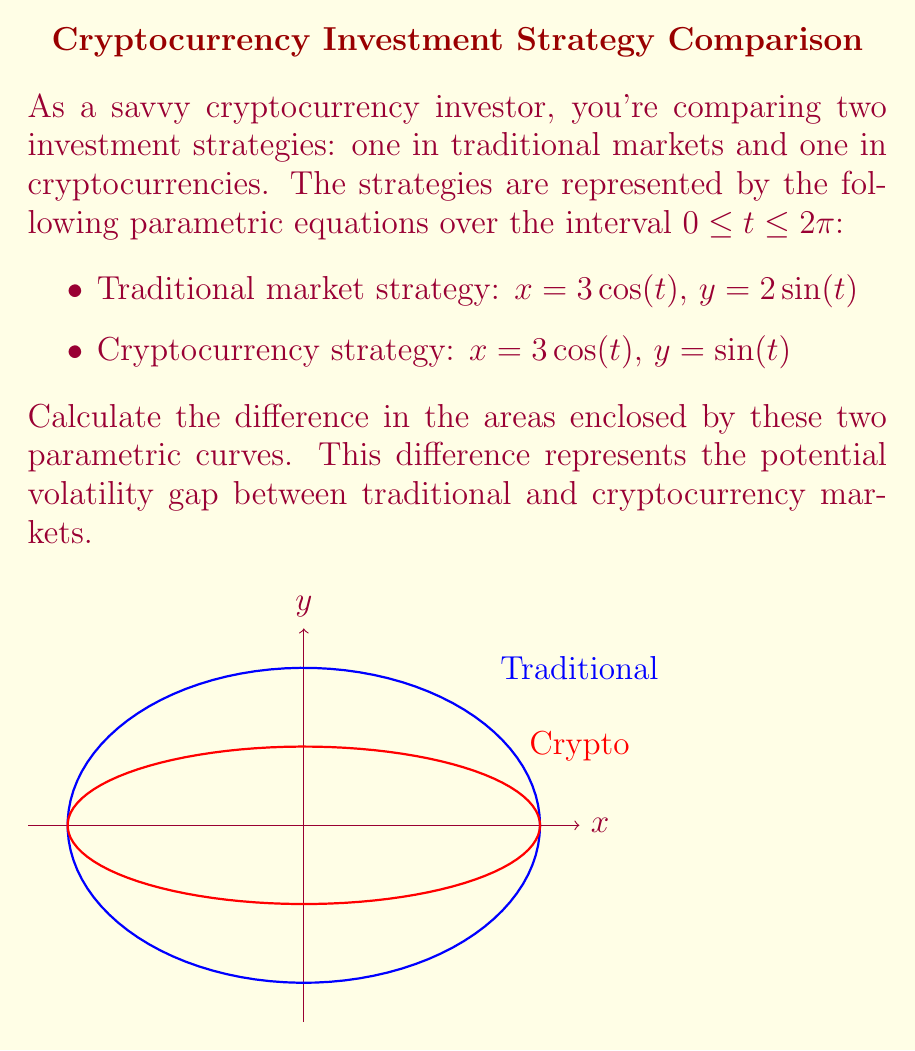Teach me how to tackle this problem. Let's approach this step-by-step:

1) For a parametric curve $(x(t), y(t))$ over an interval $[a,b]$, the area enclosed is given by the formula:

   $$A = \frac{1}{2}\int_a^b [x(t)y'(t) - y(t)x'(t)] dt$$

2) For the traditional market strategy:
   $x = 3\cos(t)$, $y = 2\sin(t)$
   $x' = -3\sin(t)$, $y' = 2\cos(t)$

   $$A_1 = \frac{1}{2}\int_0^{2\pi} [3\cos(t)(2\cos(t)) - 2\sin(t)(-3\sin(t))] dt$$
   $$= \frac{1}{2}\int_0^{2\pi} [6\cos^2(t) + 6\sin^2(t)] dt$$
   $$= \frac{1}{2}\int_0^{2\pi} 6 dt = 3\pi$$

3) For the cryptocurrency strategy:
   $x = 3\cos(t)$, $y = \sin(t)$
   $x' = -3\sin(t)$, $y' = \cos(t)$

   $$A_2 = \frac{1}{2}\int_0^{2\pi} [3\cos(t)(\cos(t)) - \sin(t)(-3\sin(t))] dt$$
   $$= \frac{1}{2}\int_0^{2\pi} [3\cos^2(t) + 3\sin^2(t)] dt$$
   $$= \frac{1}{2}\int_0^{2\pi} 3 dt = \frac{3\pi}{2}$$

4) The difference in areas is:
   $$A_1 - A_2 = 3\pi - \frac{3\pi}{2} = \frac{3\pi}{2}$$

Therefore, the difference in the areas enclosed by these two parametric curves is $\frac{3\pi}{2}$.
Answer: $\frac{3\pi}{2}$ 